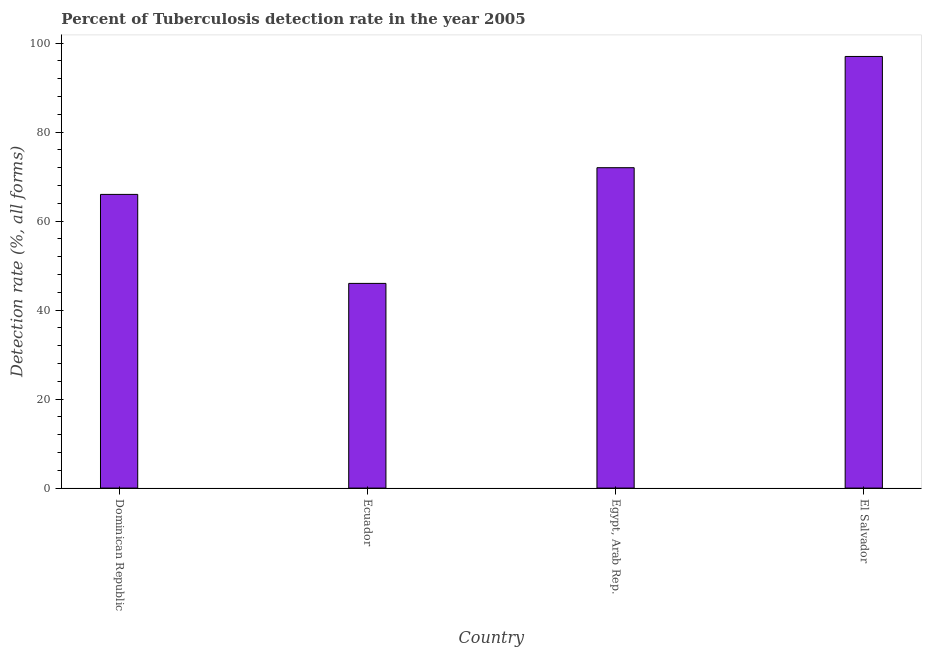Does the graph contain any zero values?
Ensure brevity in your answer.  No. Does the graph contain grids?
Your answer should be very brief. No. What is the title of the graph?
Provide a short and direct response. Percent of Tuberculosis detection rate in the year 2005. What is the label or title of the X-axis?
Offer a very short reply. Country. What is the label or title of the Y-axis?
Provide a short and direct response. Detection rate (%, all forms). What is the detection rate of tuberculosis in El Salvador?
Ensure brevity in your answer.  97. Across all countries, what is the maximum detection rate of tuberculosis?
Offer a very short reply. 97. Across all countries, what is the minimum detection rate of tuberculosis?
Keep it short and to the point. 46. In which country was the detection rate of tuberculosis maximum?
Keep it short and to the point. El Salvador. In which country was the detection rate of tuberculosis minimum?
Provide a short and direct response. Ecuador. What is the sum of the detection rate of tuberculosis?
Offer a terse response. 281. What is the difference between the detection rate of tuberculosis in Ecuador and El Salvador?
Provide a short and direct response. -51. What is the average detection rate of tuberculosis per country?
Your answer should be very brief. 70. What is the median detection rate of tuberculosis?
Give a very brief answer. 69. What is the ratio of the detection rate of tuberculosis in Ecuador to that in Egypt, Arab Rep.?
Keep it short and to the point. 0.64. Is the detection rate of tuberculosis in Dominican Republic less than that in Egypt, Arab Rep.?
Your answer should be compact. Yes. Is the difference between the detection rate of tuberculosis in Ecuador and Egypt, Arab Rep. greater than the difference between any two countries?
Offer a terse response. No. What is the difference between the highest and the second highest detection rate of tuberculosis?
Your answer should be compact. 25. Is the sum of the detection rate of tuberculosis in Egypt, Arab Rep. and El Salvador greater than the maximum detection rate of tuberculosis across all countries?
Give a very brief answer. Yes. What is the difference between the highest and the lowest detection rate of tuberculosis?
Make the answer very short. 51. In how many countries, is the detection rate of tuberculosis greater than the average detection rate of tuberculosis taken over all countries?
Ensure brevity in your answer.  2. How many bars are there?
Your answer should be compact. 4. Are the values on the major ticks of Y-axis written in scientific E-notation?
Your response must be concise. No. What is the Detection rate (%, all forms) of Dominican Republic?
Give a very brief answer. 66. What is the Detection rate (%, all forms) in Egypt, Arab Rep.?
Your answer should be compact. 72. What is the Detection rate (%, all forms) of El Salvador?
Keep it short and to the point. 97. What is the difference between the Detection rate (%, all forms) in Dominican Republic and Ecuador?
Make the answer very short. 20. What is the difference between the Detection rate (%, all forms) in Dominican Republic and El Salvador?
Offer a terse response. -31. What is the difference between the Detection rate (%, all forms) in Ecuador and El Salvador?
Provide a short and direct response. -51. What is the ratio of the Detection rate (%, all forms) in Dominican Republic to that in Ecuador?
Provide a short and direct response. 1.44. What is the ratio of the Detection rate (%, all forms) in Dominican Republic to that in Egypt, Arab Rep.?
Make the answer very short. 0.92. What is the ratio of the Detection rate (%, all forms) in Dominican Republic to that in El Salvador?
Make the answer very short. 0.68. What is the ratio of the Detection rate (%, all forms) in Ecuador to that in Egypt, Arab Rep.?
Provide a succinct answer. 0.64. What is the ratio of the Detection rate (%, all forms) in Ecuador to that in El Salvador?
Provide a succinct answer. 0.47. What is the ratio of the Detection rate (%, all forms) in Egypt, Arab Rep. to that in El Salvador?
Provide a short and direct response. 0.74. 